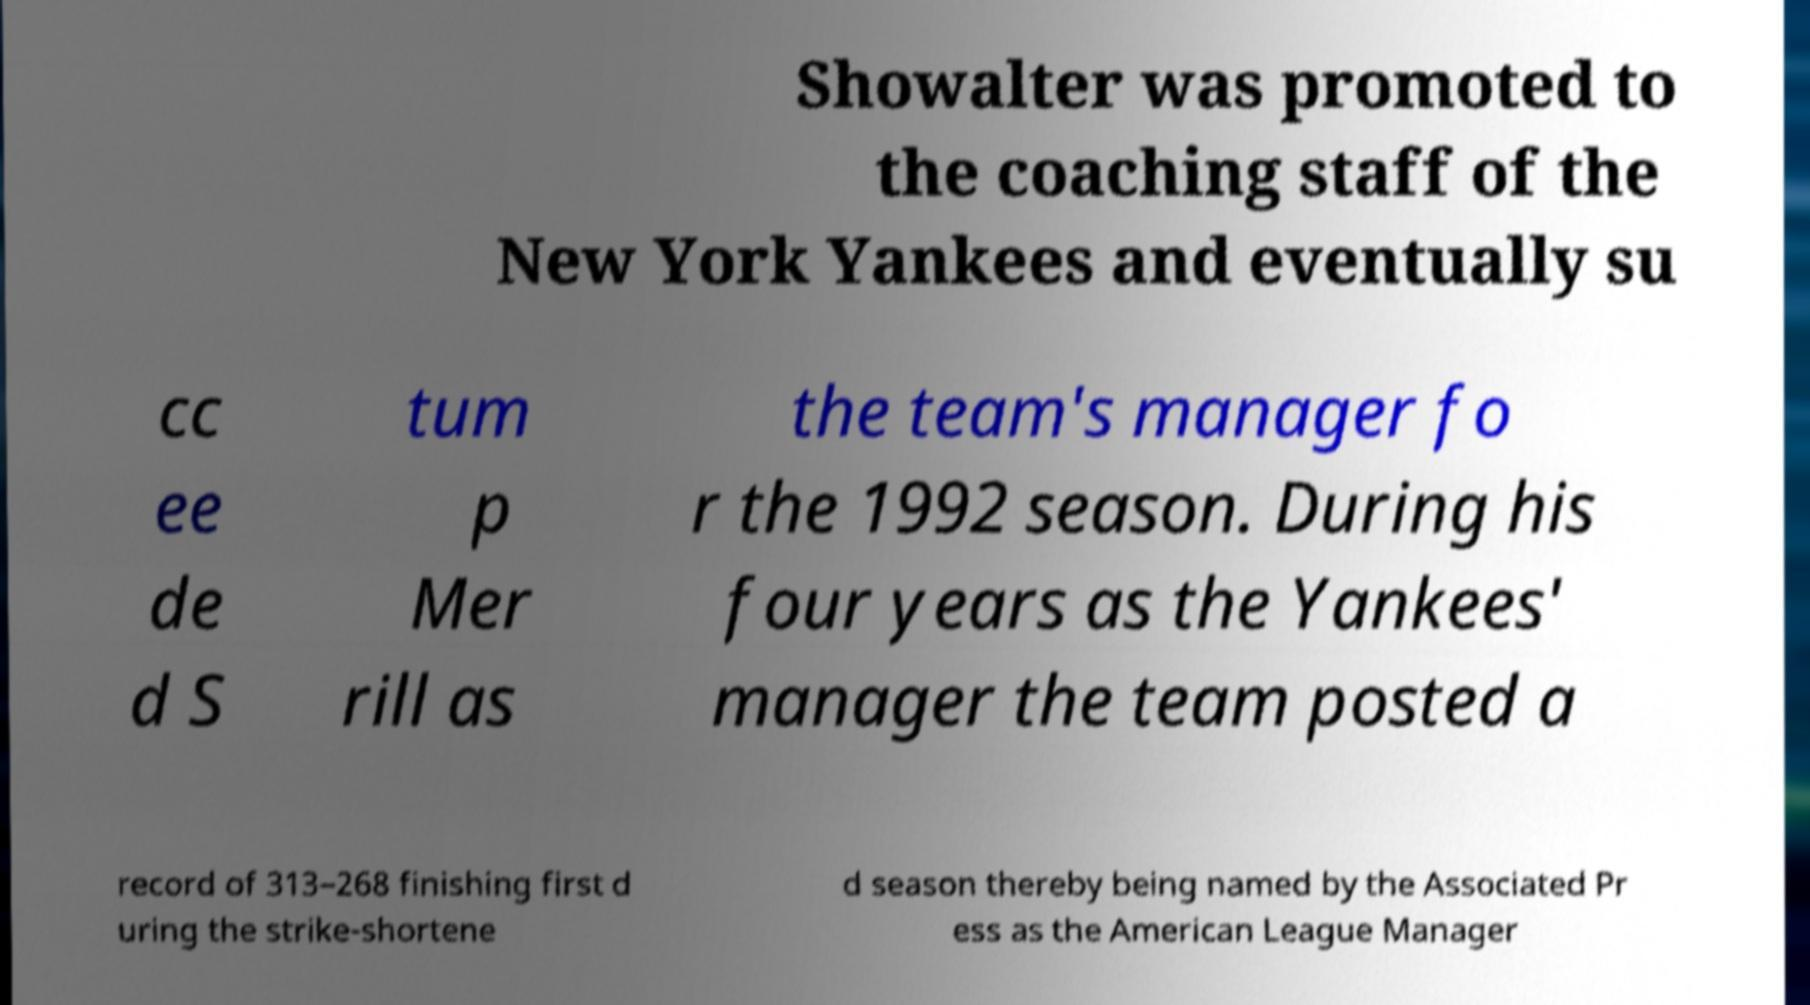What messages or text are displayed in this image? I need them in a readable, typed format. Showalter was promoted to the coaching staff of the New York Yankees and eventually su cc ee de d S tum p Mer rill as the team's manager fo r the 1992 season. During his four years as the Yankees' manager the team posted a record of 313–268 finishing first d uring the strike-shortene d season thereby being named by the Associated Pr ess as the American League Manager 